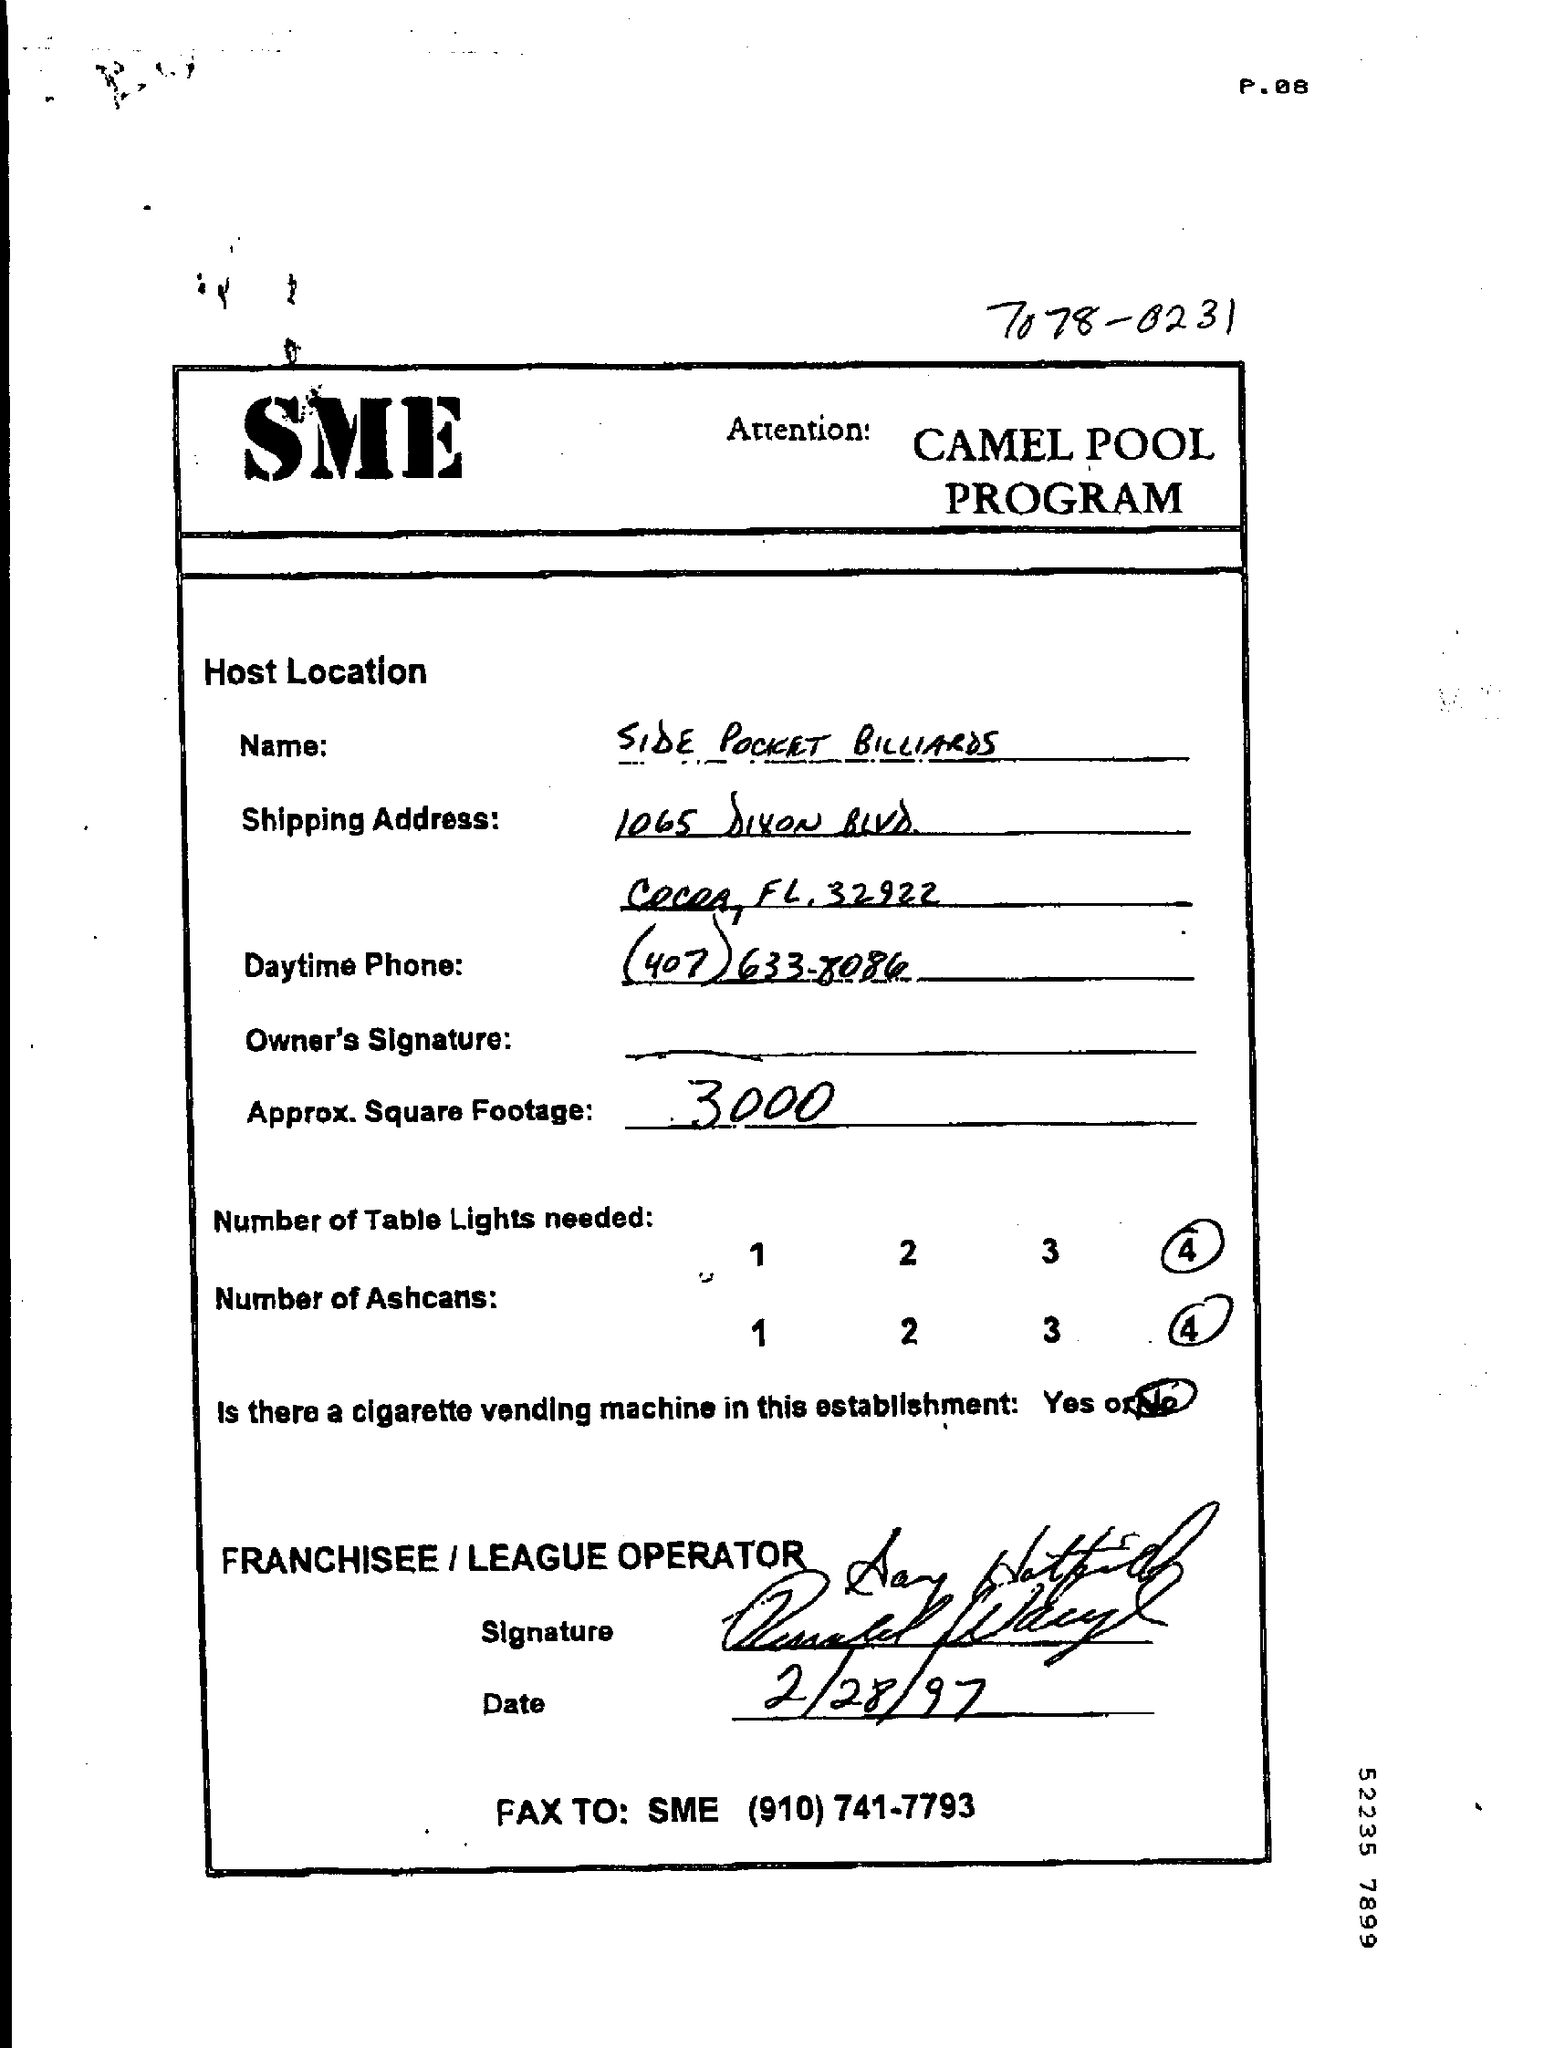Point out several critical features in this image. According to the provided page, 4 table lights are needed. There is not a cigarette vending machine in this establishment. The date mentioned in the given page is February 28, 1997. The approximate square footage value given on the page is 3000. According to the given page, 4 ashcans are needed. 